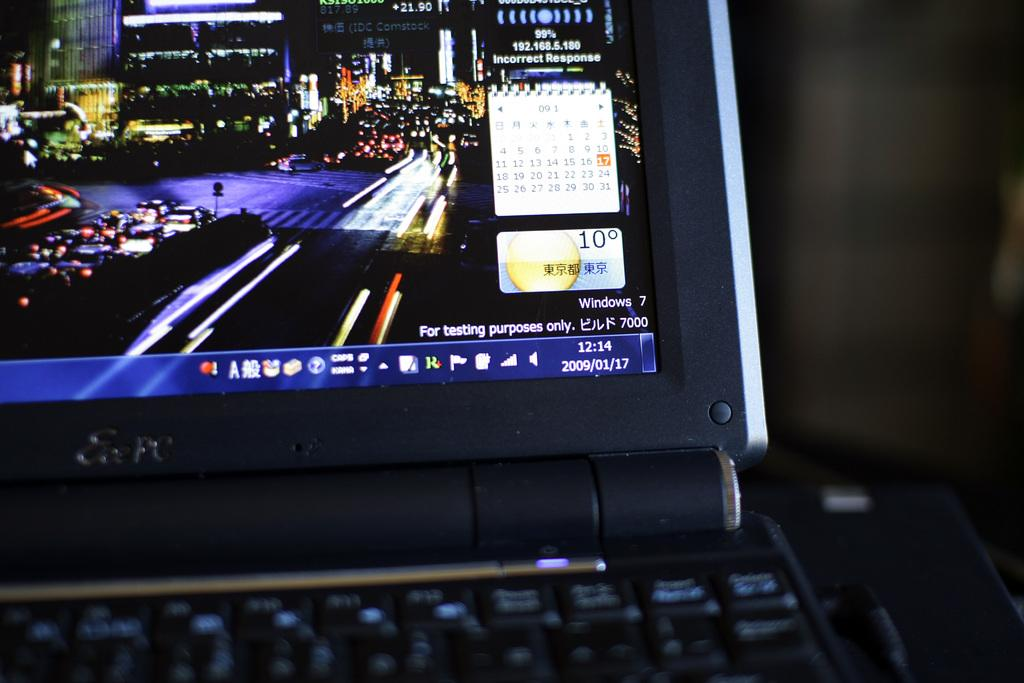<image>
Give a short and clear explanation of the subsequent image. a computer monitor with a display on a Windows 7 